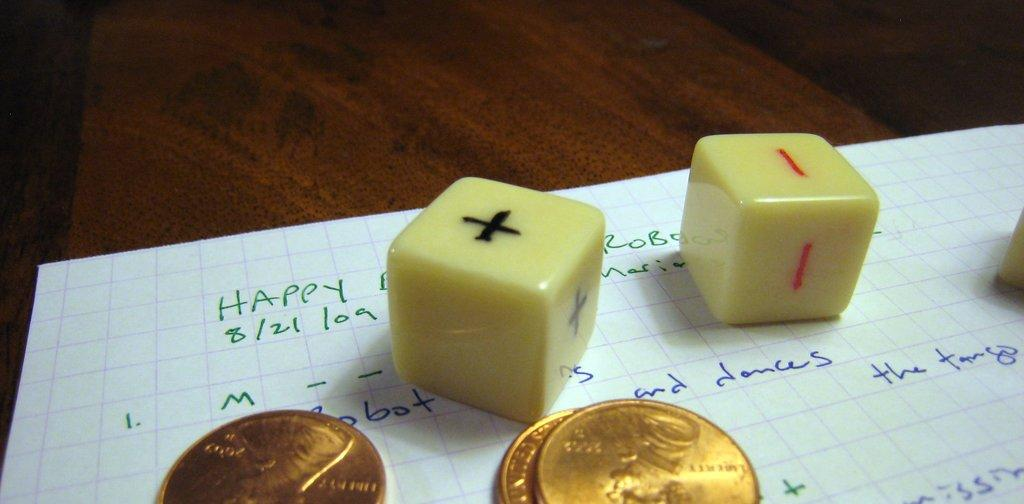<image>
Describe the image concisely. The date 8/21/09 is hand written in green on a piece of graph paper. 